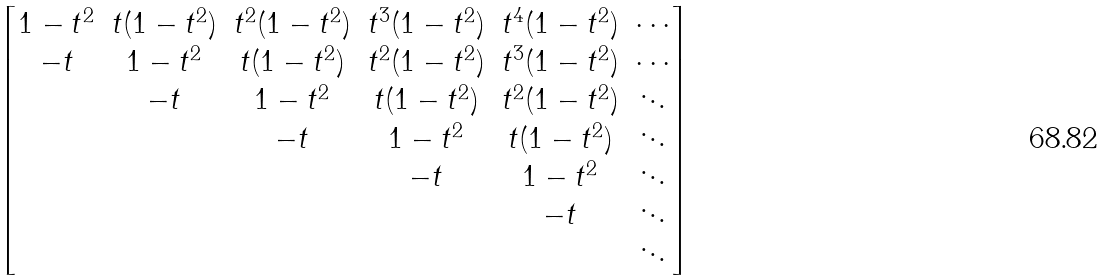Convert formula to latex. <formula><loc_0><loc_0><loc_500><loc_500>\begin{bmatrix} { 1 - t ^ { 2 } } & t ( { 1 - t ^ { 2 } } ) & t ^ { 2 } ( { 1 - t ^ { 2 } } ) & t ^ { 3 } ( { 1 - t ^ { 2 } } ) & t ^ { 4 } ( { 1 - t ^ { 2 } } ) & \cdots \\ - t & 1 - t ^ { 2 } & t ( 1 - t ^ { 2 } ) & t ^ { 2 } ( 1 - t ^ { 2 } ) & t ^ { 3 } ( 1 - t ^ { 2 } ) & \cdots \\ & - t & 1 - t ^ { 2 } & t ( 1 - t ^ { 2 } ) & t ^ { 2 } ( 1 - t ^ { 2 } ) & \ddots \\ & & - t & 1 - t ^ { 2 } & t ( 1 - t ^ { 2 } ) & \ddots \\ & & & - t & 1 - t ^ { 2 } & \ddots \\ & & & & - t & \ddots \\ & & & & & \ddots \\ \end{bmatrix}</formula> 